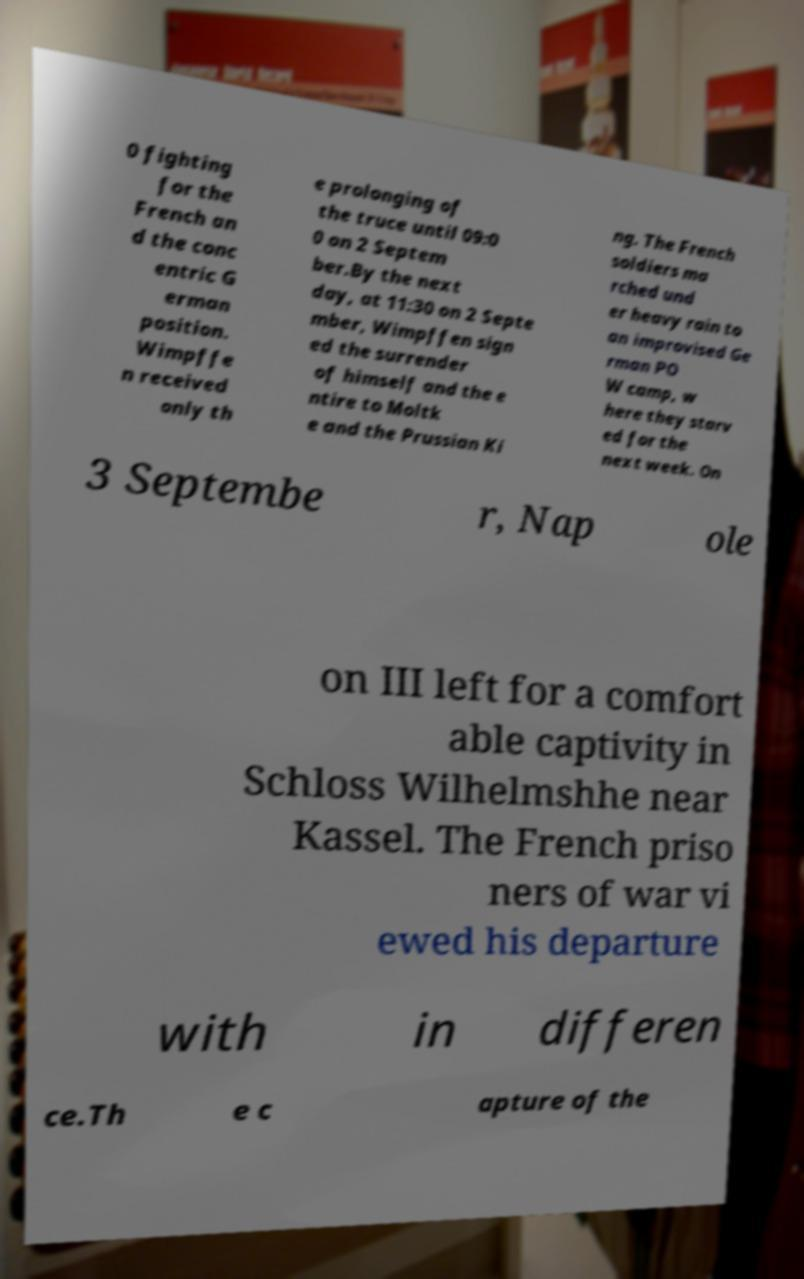Could you extract and type out the text from this image? 0 fighting for the French an d the conc entric G erman position. Wimpffe n received only th e prolonging of the truce until 09:0 0 on 2 Septem ber.By the next day, at 11:30 on 2 Septe mber, Wimpffen sign ed the surrender of himself and the e ntire to Moltk e and the Prussian Ki ng. The French soldiers ma rched und er heavy rain to an improvised Ge rman PO W camp, w here they starv ed for the next week. On 3 Septembe r, Nap ole on III left for a comfort able captivity in Schloss Wilhelmshhe near Kassel. The French priso ners of war vi ewed his departure with in differen ce.Th e c apture of the 